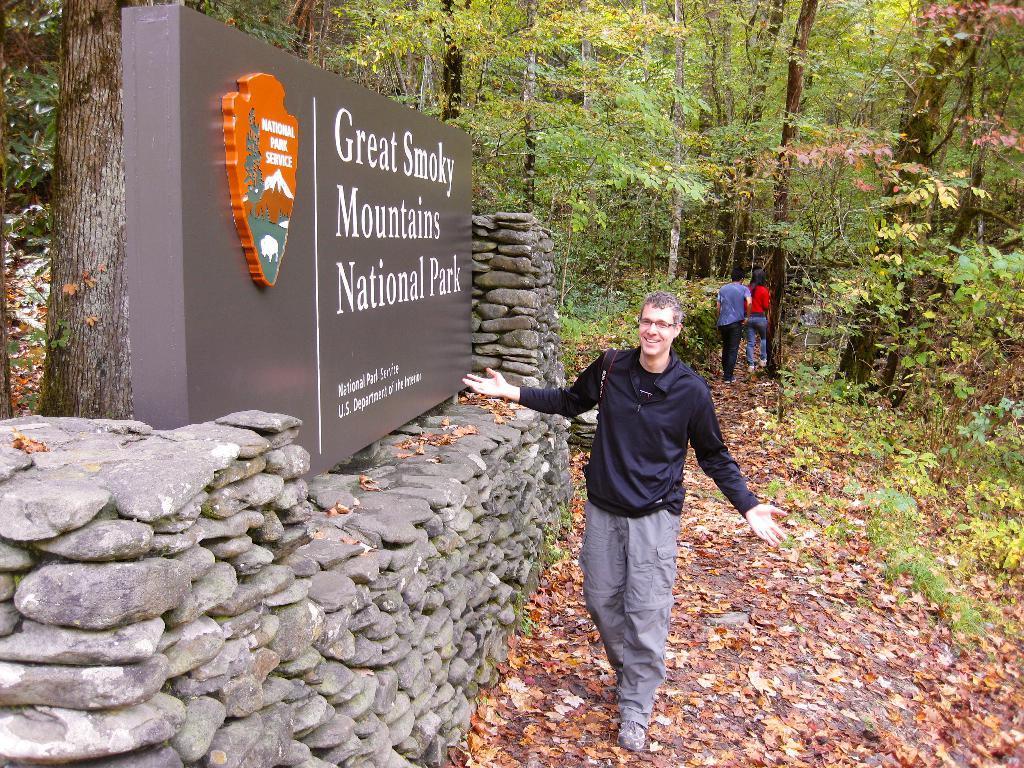In one or two sentences, can you explain what this image depicts? In this picture we can see a man standing in the front, at the bottom there are some plants and leaves, on the left side there is a board, we can see stones here, in the background there are some trees, we can see two persons walking here. 